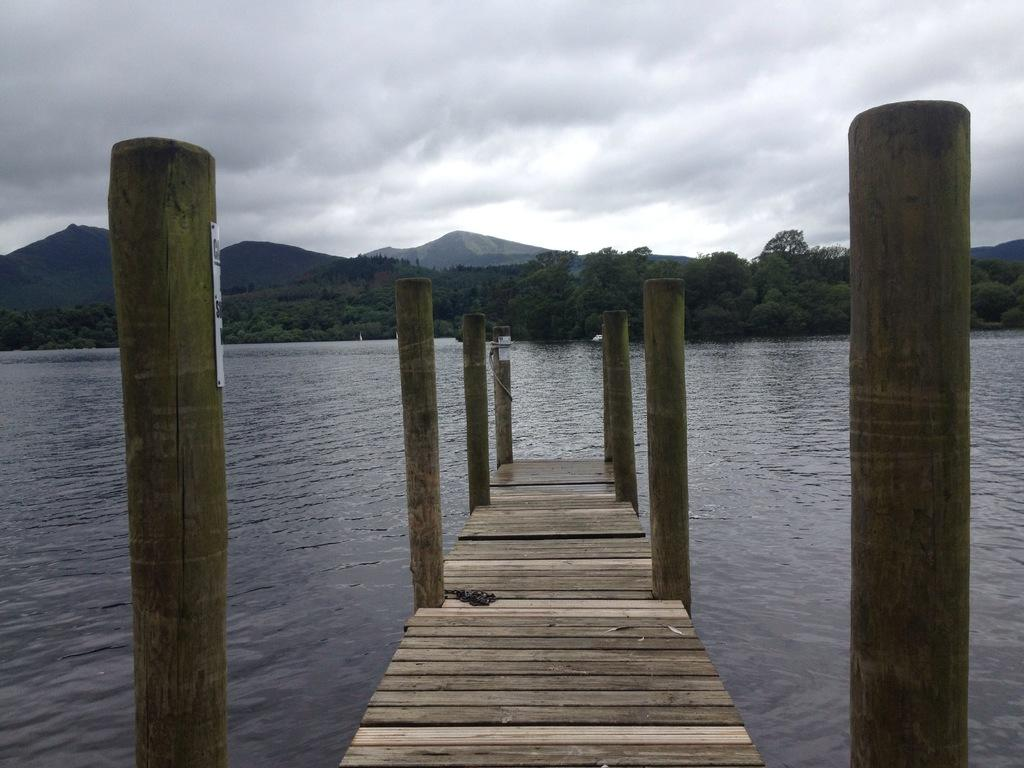What is the main structure in the center of the image? There is a dock in the center of the picture. What can be seen in the foreground of the image? There is a water body in the foreground of the image. What other elements are present in the center of the picture? There are trees and hills in the center of the picture. How would you describe the sky in the image? The sky is cloudy in the image. What flavor of ice cream is being served on the dock in the image? There is no ice cream present in the image, and therefore no flavor can be determined. 